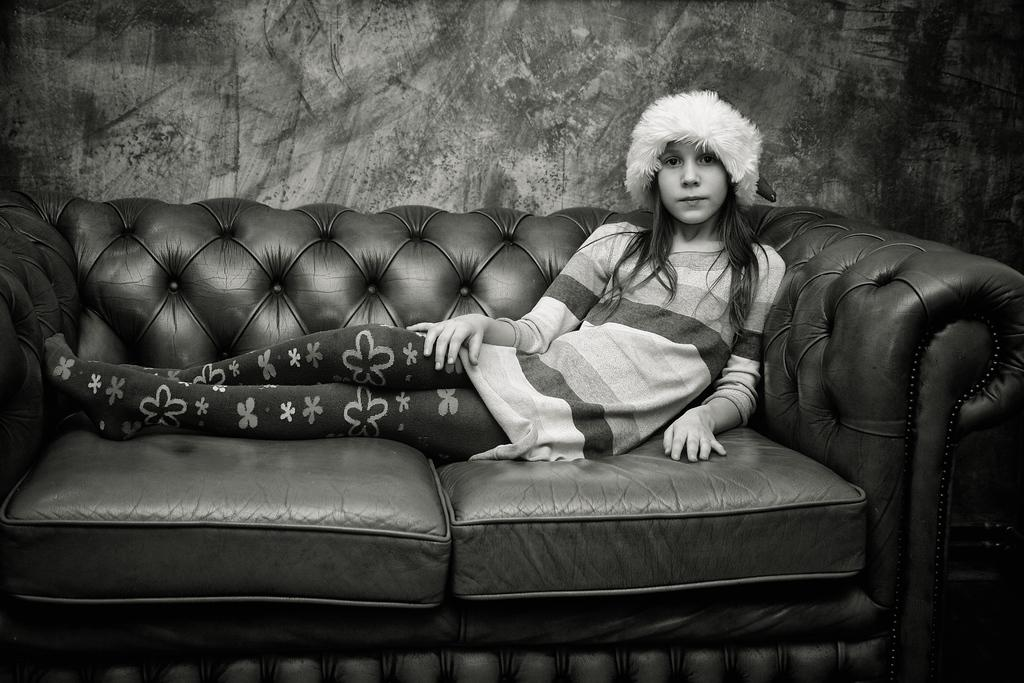Who is the main subject in the image? There is a girl in the image. What is the girl doing in the image? The girl is sitting on a sofa. What is the girl wearing on her head? The girl is wearing a white hat. What is the color scheme of the image? The image is in black and white color. What type of ball is the beggar holding in the image? There is no ball or beggar present in the image; it features a girl sitting on a sofa wearing a white hat. 